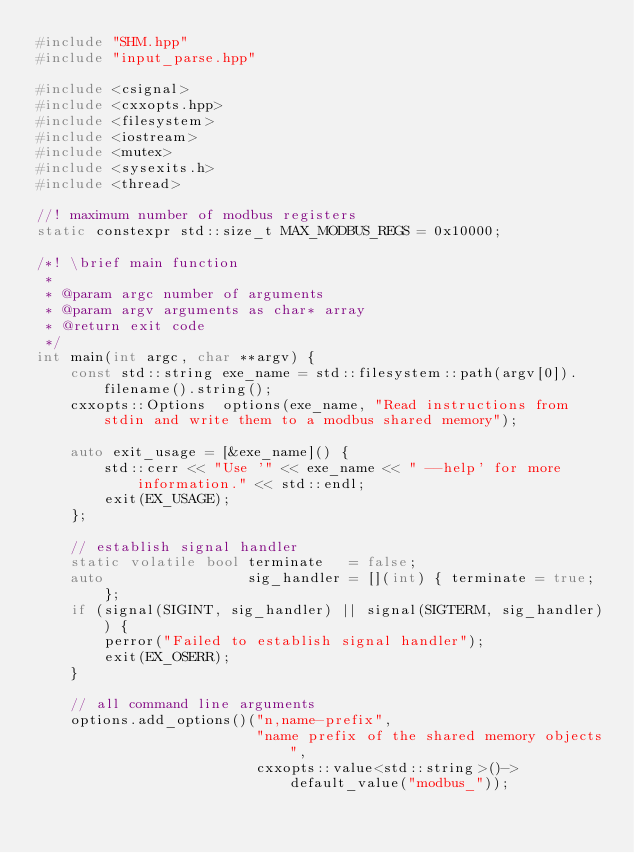Convert code to text. <code><loc_0><loc_0><loc_500><loc_500><_C++_>#include "SHM.hpp"
#include "input_parse.hpp"

#include <csignal>
#include <cxxopts.hpp>
#include <filesystem>
#include <iostream>
#include <mutex>
#include <sysexits.h>
#include <thread>

//! maximum number of modbus registers
static constexpr std::size_t MAX_MODBUS_REGS = 0x10000;

/*! \brief main function
 *
 * @param argc number of arguments
 * @param argv arguments as char* array
 * @return exit code
 */
int main(int argc, char **argv) {
    const std::string exe_name = std::filesystem::path(argv[0]).filename().string();
    cxxopts::Options  options(exe_name, "Read instructions from stdin and write them to a modbus shared memory");

    auto exit_usage = [&exe_name]() {
        std::cerr << "Use '" << exe_name << " --help' for more information." << std::endl;
        exit(EX_USAGE);
    };

    // establish signal handler
    static volatile bool terminate   = false;
    auto                 sig_handler = [](int) { terminate = true; };
    if (signal(SIGINT, sig_handler) || signal(SIGTERM, sig_handler)) {
        perror("Failed to establish signal handler");
        exit(EX_OSERR);
    }

    // all command line arguments
    options.add_options()("n,name-prefix",
                          "name prefix of the shared memory objects",
                          cxxopts::value<std::string>()->default_value("modbus_"));</code> 